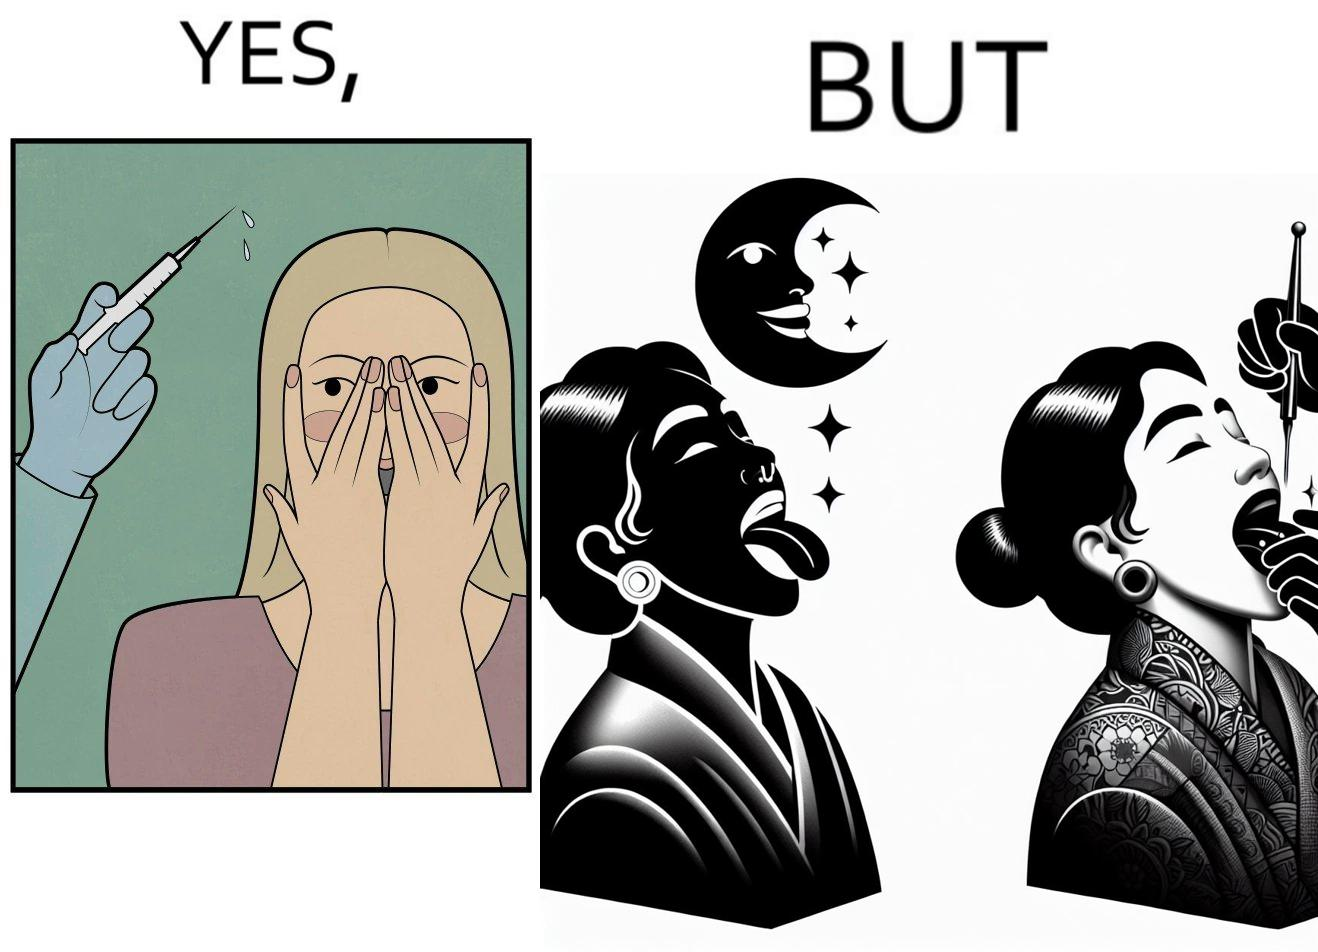What is the satirical meaning behind this image? The image is funny becuase while the woman is scared of getting an injection which is for her benefit, she is not afraid of getting a piercing or a tattoo which are not going to help her in any way. 